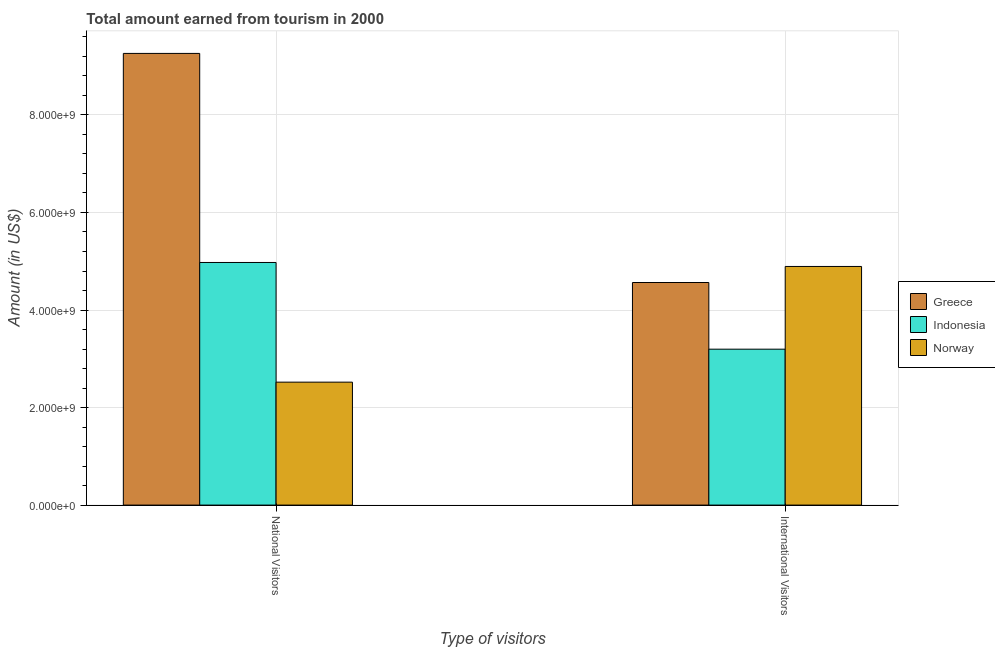How many different coloured bars are there?
Offer a very short reply. 3. How many groups of bars are there?
Offer a terse response. 2. Are the number of bars on each tick of the X-axis equal?
Provide a succinct answer. Yes. How many bars are there on the 1st tick from the left?
Give a very brief answer. 3. What is the label of the 1st group of bars from the left?
Provide a succinct answer. National Visitors. What is the amount earned from national visitors in Greece?
Make the answer very short. 9.26e+09. Across all countries, what is the maximum amount earned from international visitors?
Your response must be concise. 4.89e+09. Across all countries, what is the minimum amount earned from national visitors?
Offer a very short reply. 2.52e+09. In which country was the amount earned from international visitors minimum?
Your response must be concise. Indonesia. What is the total amount earned from international visitors in the graph?
Your answer should be compact. 1.27e+1. What is the difference between the amount earned from national visitors in Norway and that in Greece?
Provide a short and direct response. -6.74e+09. What is the difference between the amount earned from international visitors in Norway and the amount earned from national visitors in Indonesia?
Offer a terse response. -8.20e+07. What is the average amount earned from national visitors per country?
Make the answer very short. 5.59e+09. What is the difference between the amount earned from international visitors and amount earned from national visitors in Greece?
Offer a terse response. -4.70e+09. What is the ratio of the amount earned from international visitors in Indonesia to that in Greece?
Your answer should be compact. 0.7. Is the amount earned from international visitors in Greece less than that in Norway?
Your answer should be very brief. Yes. What does the 2nd bar from the right in International Visitors represents?
Give a very brief answer. Indonesia. What is the difference between two consecutive major ticks on the Y-axis?
Your answer should be compact. 2.00e+09. Are the values on the major ticks of Y-axis written in scientific E-notation?
Provide a succinct answer. Yes. Does the graph contain grids?
Provide a succinct answer. Yes. How are the legend labels stacked?
Offer a very short reply. Vertical. What is the title of the graph?
Provide a succinct answer. Total amount earned from tourism in 2000. What is the label or title of the X-axis?
Provide a succinct answer. Type of visitors. What is the Amount (in US$) of Greece in National Visitors?
Make the answer very short. 9.26e+09. What is the Amount (in US$) of Indonesia in National Visitors?
Offer a terse response. 4.98e+09. What is the Amount (in US$) of Norway in National Visitors?
Your answer should be compact. 2.52e+09. What is the Amount (in US$) of Greece in International Visitors?
Your response must be concise. 4.56e+09. What is the Amount (in US$) in Indonesia in International Visitors?
Your answer should be very brief. 3.20e+09. What is the Amount (in US$) of Norway in International Visitors?
Offer a terse response. 4.89e+09. Across all Type of visitors, what is the maximum Amount (in US$) in Greece?
Offer a terse response. 9.26e+09. Across all Type of visitors, what is the maximum Amount (in US$) of Indonesia?
Make the answer very short. 4.98e+09. Across all Type of visitors, what is the maximum Amount (in US$) in Norway?
Give a very brief answer. 4.89e+09. Across all Type of visitors, what is the minimum Amount (in US$) in Greece?
Your answer should be very brief. 4.56e+09. Across all Type of visitors, what is the minimum Amount (in US$) of Indonesia?
Give a very brief answer. 3.20e+09. Across all Type of visitors, what is the minimum Amount (in US$) of Norway?
Provide a short and direct response. 2.52e+09. What is the total Amount (in US$) in Greece in the graph?
Give a very brief answer. 1.38e+1. What is the total Amount (in US$) in Indonesia in the graph?
Make the answer very short. 8.17e+09. What is the total Amount (in US$) in Norway in the graph?
Offer a terse response. 7.41e+09. What is the difference between the Amount (in US$) in Greece in National Visitors and that in International Visitors?
Offer a terse response. 4.70e+09. What is the difference between the Amount (in US$) of Indonesia in National Visitors and that in International Visitors?
Offer a terse response. 1.78e+09. What is the difference between the Amount (in US$) in Norway in National Visitors and that in International Visitors?
Your answer should be very brief. -2.37e+09. What is the difference between the Amount (in US$) in Greece in National Visitors and the Amount (in US$) in Indonesia in International Visitors?
Make the answer very short. 6.06e+09. What is the difference between the Amount (in US$) in Greece in National Visitors and the Amount (in US$) in Norway in International Visitors?
Keep it short and to the point. 4.37e+09. What is the difference between the Amount (in US$) in Indonesia in National Visitors and the Amount (in US$) in Norway in International Visitors?
Offer a very short reply. 8.20e+07. What is the average Amount (in US$) in Greece per Type of visitors?
Provide a succinct answer. 6.91e+09. What is the average Amount (in US$) in Indonesia per Type of visitors?
Keep it short and to the point. 4.09e+09. What is the average Amount (in US$) in Norway per Type of visitors?
Ensure brevity in your answer.  3.71e+09. What is the difference between the Amount (in US$) of Greece and Amount (in US$) of Indonesia in National Visitors?
Make the answer very short. 4.29e+09. What is the difference between the Amount (in US$) in Greece and Amount (in US$) in Norway in National Visitors?
Ensure brevity in your answer.  6.74e+09. What is the difference between the Amount (in US$) in Indonesia and Amount (in US$) in Norway in National Visitors?
Give a very brief answer. 2.45e+09. What is the difference between the Amount (in US$) of Greece and Amount (in US$) of Indonesia in International Visitors?
Provide a succinct answer. 1.37e+09. What is the difference between the Amount (in US$) in Greece and Amount (in US$) in Norway in International Visitors?
Your answer should be very brief. -3.29e+08. What is the difference between the Amount (in US$) of Indonesia and Amount (in US$) of Norway in International Visitors?
Offer a terse response. -1.70e+09. What is the ratio of the Amount (in US$) of Greece in National Visitors to that in International Visitors?
Ensure brevity in your answer.  2.03. What is the ratio of the Amount (in US$) in Indonesia in National Visitors to that in International Visitors?
Your answer should be compact. 1.56. What is the ratio of the Amount (in US$) in Norway in National Visitors to that in International Visitors?
Offer a very short reply. 0.52. What is the difference between the highest and the second highest Amount (in US$) in Greece?
Offer a very short reply. 4.70e+09. What is the difference between the highest and the second highest Amount (in US$) of Indonesia?
Provide a short and direct response. 1.78e+09. What is the difference between the highest and the second highest Amount (in US$) in Norway?
Keep it short and to the point. 2.37e+09. What is the difference between the highest and the lowest Amount (in US$) of Greece?
Offer a terse response. 4.70e+09. What is the difference between the highest and the lowest Amount (in US$) in Indonesia?
Ensure brevity in your answer.  1.78e+09. What is the difference between the highest and the lowest Amount (in US$) in Norway?
Give a very brief answer. 2.37e+09. 